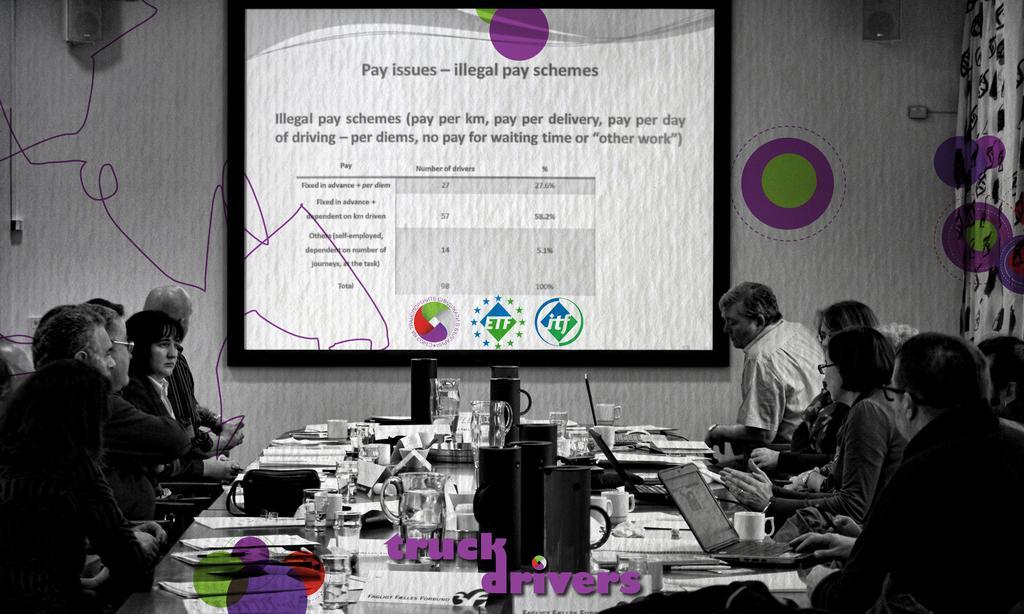Can you describe this image briefly? In this image in the center there are jars, papers, laptops and glasses on the table and there are persons sitting on the chair. In the background there is a screen and on the screen there is some text visible and on the wall there are speakers. On the right side there is a curtain. 